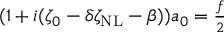<formula> <loc_0><loc_0><loc_500><loc_500>\begin{array} { r } { ( 1 + i ( \zeta _ { 0 } - \delta \zeta _ { N L } - \beta ) ) a _ { 0 } = \frac { f } { 2 } } \end{array}</formula> 